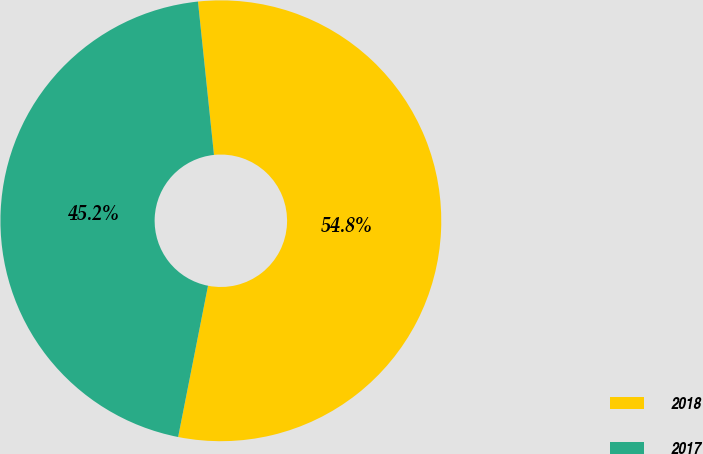<chart> <loc_0><loc_0><loc_500><loc_500><pie_chart><fcel>2018<fcel>2017<nl><fcel>54.76%<fcel>45.24%<nl></chart> 